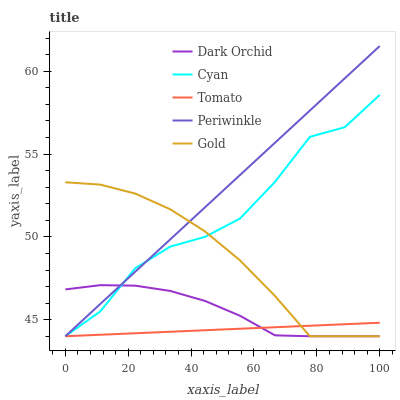Does Tomato have the minimum area under the curve?
Answer yes or no. Yes. Does Periwinkle have the maximum area under the curve?
Answer yes or no. Yes. Does Cyan have the minimum area under the curve?
Answer yes or no. No. Does Cyan have the maximum area under the curve?
Answer yes or no. No. Is Tomato the smoothest?
Answer yes or no. Yes. Is Cyan the roughest?
Answer yes or no. Yes. Is Periwinkle the smoothest?
Answer yes or no. No. Is Periwinkle the roughest?
Answer yes or no. No. Does Tomato have the lowest value?
Answer yes or no. Yes. Does Periwinkle have the highest value?
Answer yes or no. Yes. Does Cyan have the highest value?
Answer yes or no. No. Does Cyan intersect Dark Orchid?
Answer yes or no. Yes. Is Cyan less than Dark Orchid?
Answer yes or no. No. Is Cyan greater than Dark Orchid?
Answer yes or no. No. 